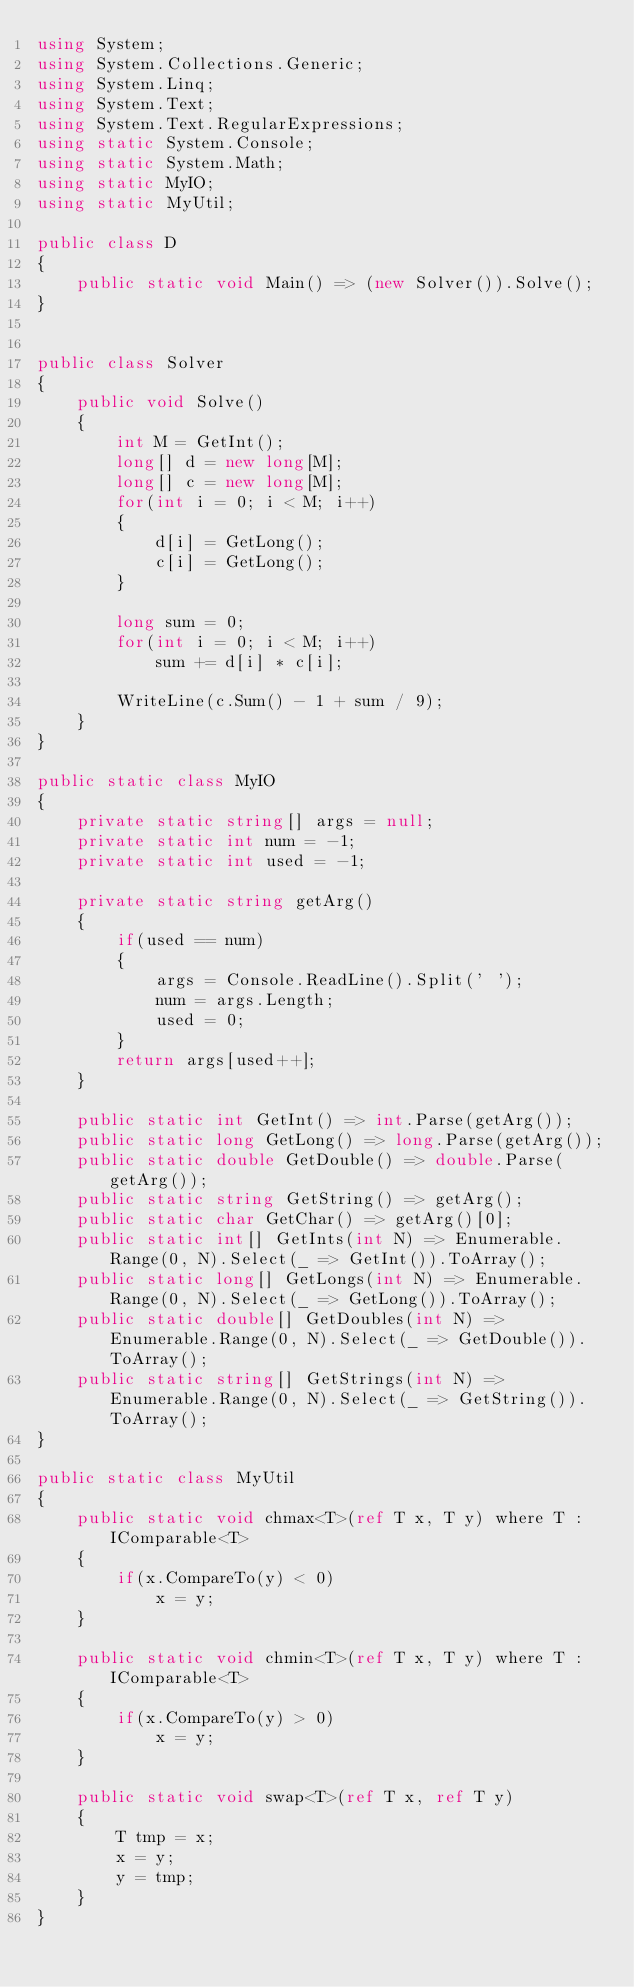<code> <loc_0><loc_0><loc_500><loc_500><_C#_>using System;
using System.Collections.Generic;
using System.Linq;
using System.Text;
using System.Text.RegularExpressions;
using static System.Console;
using static System.Math;
using static MyIO;
using static MyUtil;

public class D
{
	public static void Main() => (new Solver()).Solve();
}


public class Solver
{
	public void Solve()
	{
		int M = GetInt();
		long[] d = new long[M];
		long[] c = new long[M];
		for(int i = 0; i < M; i++)
		{
			d[i] = GetLong();
			c[i] = GetLong();
		}

		long sum = 0;
		for(int i = 0; i < M; i++)
			sum += d[i] * c[i];

		WriteLine(c.Sum() - 1 + sum / 9);
	}
}

public static class MyIO
{
	private static string[] args = null;
	private static int num = -1;
	private static int used = -1;

	private static string getArg()
	{
		if(used == num)
		{
			args = Console.ReadLine().Split(' ');
			num = args.Length;
			used = 0;
		}
		return args[used++];
	}

	public static int GetInt() => int.Parse(getArg());
	public static long GetLong() => long.Parse(getArg());
	public static double GetDouble() => double.Parse(getArg());
	public static string GetString() => getArg();
	public static char GetChar() => getArg()[0];
	public static int[] GetInts(int N) => Enumerable.Range(0, N).Select(_ => GetInt()).ToArray();
	public static long[] GetLongs(int N) => Enumerable.Range(0, N).Select(_ => GetLong()).ToArray();
	public static double[] GetDoubles(int N) => Enumerable.Range(0, N).Select(_ => GetDouble()).ToArray();
	public static string[] GetStrings(int N) => Enumerable.Range(0, N).Select(_ => GetString()).ToArray();
}

public static class MyUtil
{
	public static void chmax<T>(ref T x, T y) where T : IComparable<T>
	{
		if(x.CompareTo(y) < 0)
			x = y;
	}

	public static void chmin<T>(ref T x, T y) where T : IComparable<T>
	{
		if(x.CompareTo(y) > 0)
			x = y;
	}

	public static void swap<T>(ref T x, ref T y)
	{
		T tmp = x;
		x = y;
		y = tmp;
	}
}</code> 